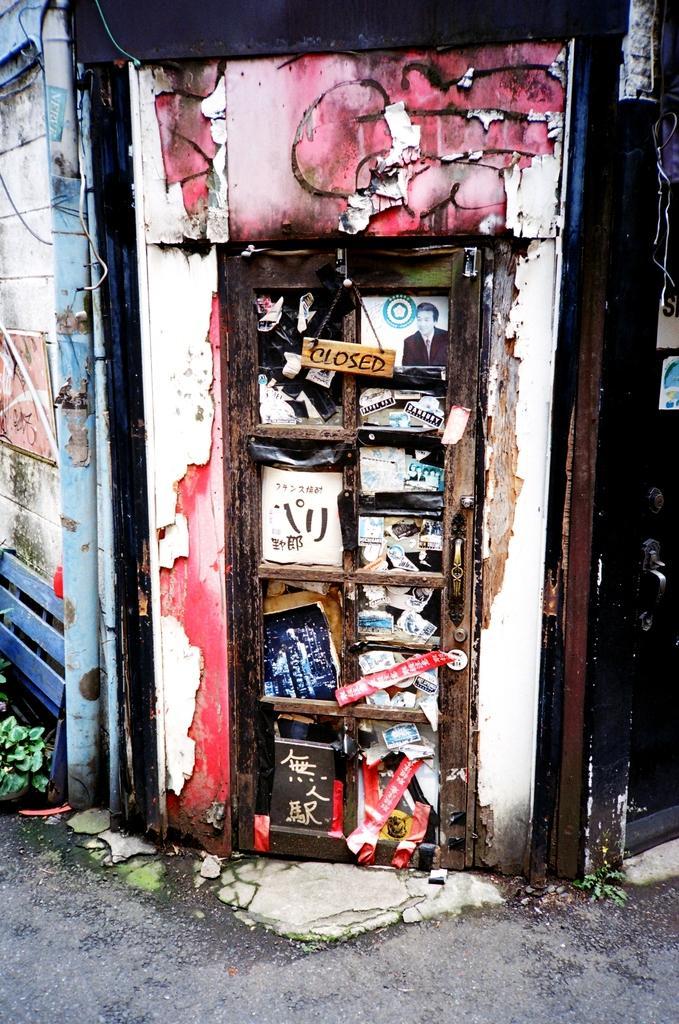Can you describe this image briefly? In this picture we can see a board and few papers on the door, and also we can see a pipe on the wall. 